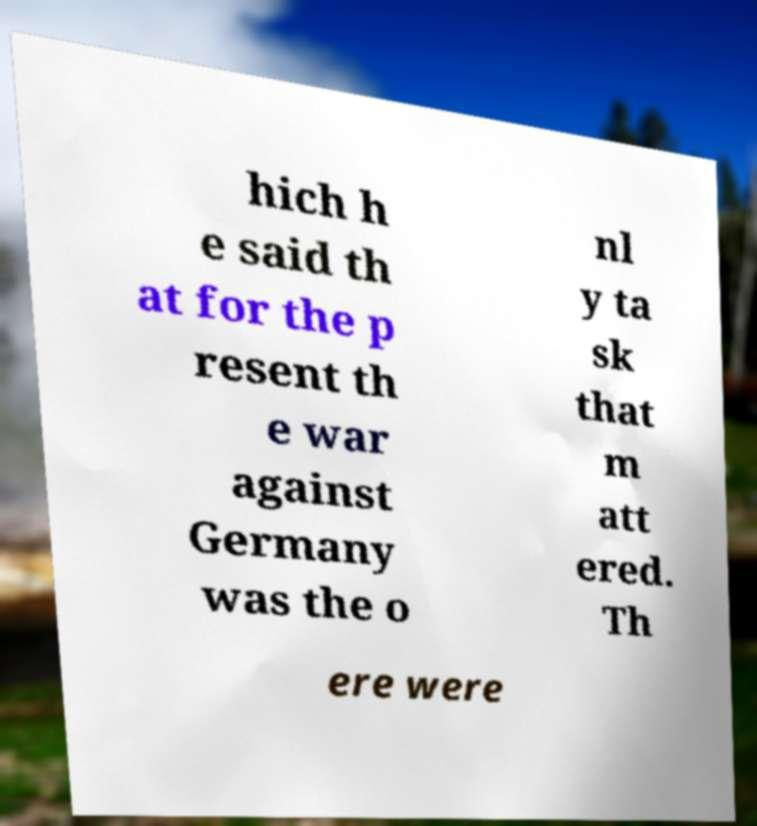There's text embedded in this image that I need extracted. Can you transcribe it verbatim? hich h e said th at for the p resent th e war against Germany was the o nl y ta sk that m att ered. Th ere were 